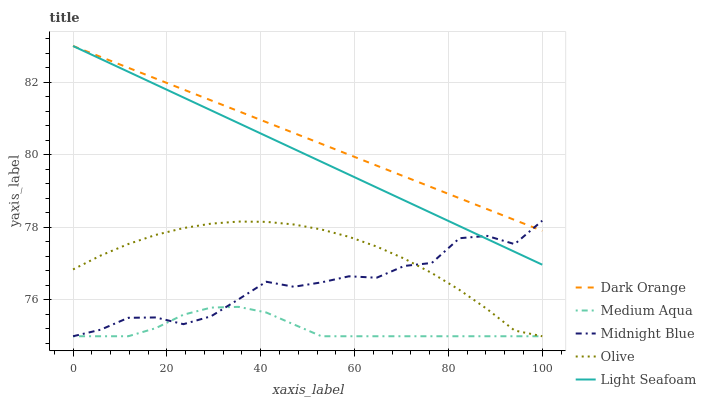Does Light Seafoam have the minimum area under the curve?
Answer yes or no. No. Does Light Seafoam have the maximum area under the curve?
Answer yes or no. No. Is Light Seafoam the smoothest?
Answer yes or no. No. Is Light Seafoam the roughest?
Answer yes or no. No. Does Light Seafoam have the lowest value?
Answer yes or no. No. Does Medium Aqua have the highest value?
Answer yes or no. No. Is Medium Aqua less than Light Seafoam?
Answer yes or no. Yes. Is Dark Orange greater than Medium Aqua?
Answer yes or no. Yes. Does Medium Aqua intersect Light Seafoam?
Answer yes or no. No. 